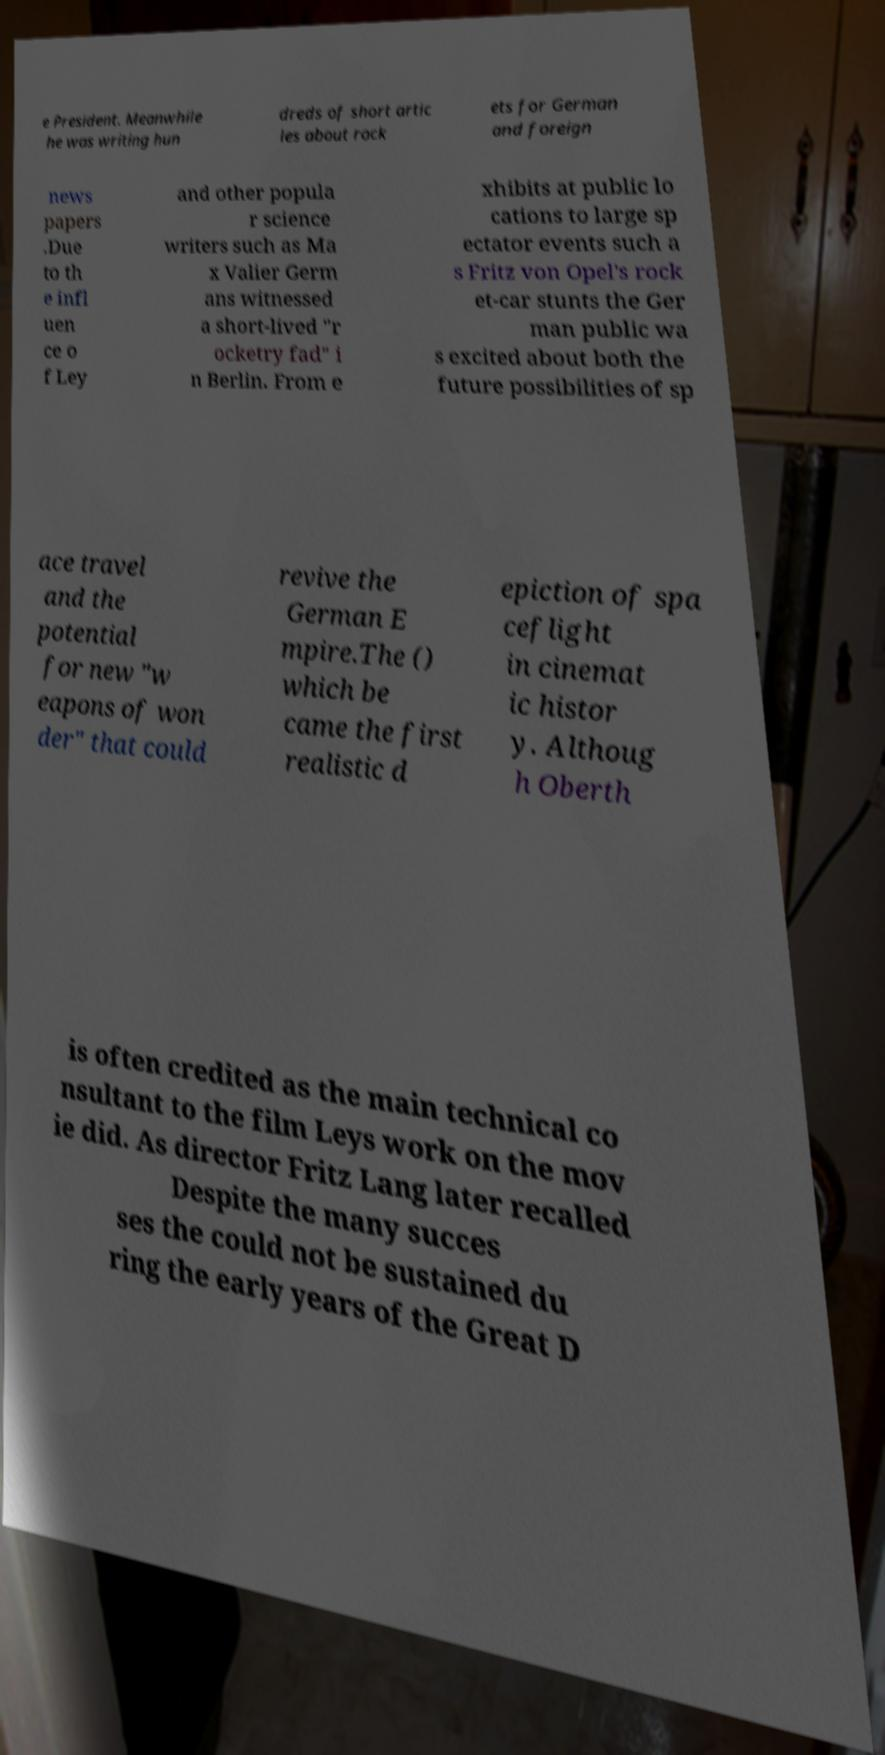Please read and relay the text visible in this image. What does it say? e President. Meanwhile he was writing hun dreds of short artic les about rock ets for German and foreign news papers .Due to th e infl uen ce o f Ley and other popula r science writers such as Ma x Valier Germ ans witnessed a short-lived "r ocketry fad" i n Berlin. From e xhibits at public lo cations to large sp ectator events such a s Fritz von Opel's rock et-car stunts the Ger man public wa s excited about both the future possibilities of sp ace travel and the potential for new "w eapons of won der" that could revive the German E mpire.The () which be came the first realistic d epiction of spa ceflight in cinemat ic histor y. Althoug h Oberth is often credited as the main technical co nsultant to the film Leys work on the mov ie did. As director Fritz Lang later recalled Despite the many succes ses the could not be sustained du ring the early years of the Great D 